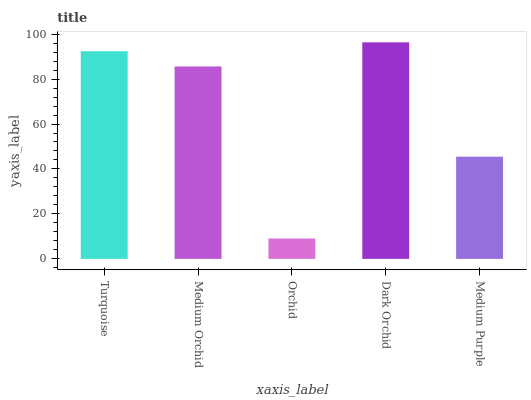Is Orchid the minimum?
Answer yes or no. Yes. Is Dark Orchid the maximum?
Answer yes or no. Yes. Is Medium Orchid the minimum?
Answer yes or no. No. Is Medium Orchid the maximum?
Answer yes or no. No. Is Turquoise greater than Medium Orchid?
Answer yes or no. Yes. Is Medium Orchid less than Turquoise?
Answer yes or no. Yes. Is Medium Orchid greater than Turquoise?
Answer yes or no. No. Is Turquoise less than Medium Orchid?
Answer yes or no. No. Is Medium Orchid the high median?
Answer yes or no. Yes. Is Medium Orchid the low median?
Answer yes or no. Yes. Is Dark Orchid the high median?
Answer yes or no. No. Is Dark Orchid the low median?
Answer yes or no. No. 